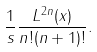<formula> <loc_0><loc_0><loc_500><loc_500>\frac { 1 } { s } \frac { L ^ { 2 n } ( x ) } { n ! ( n + 1 ) ! } .</formula> 